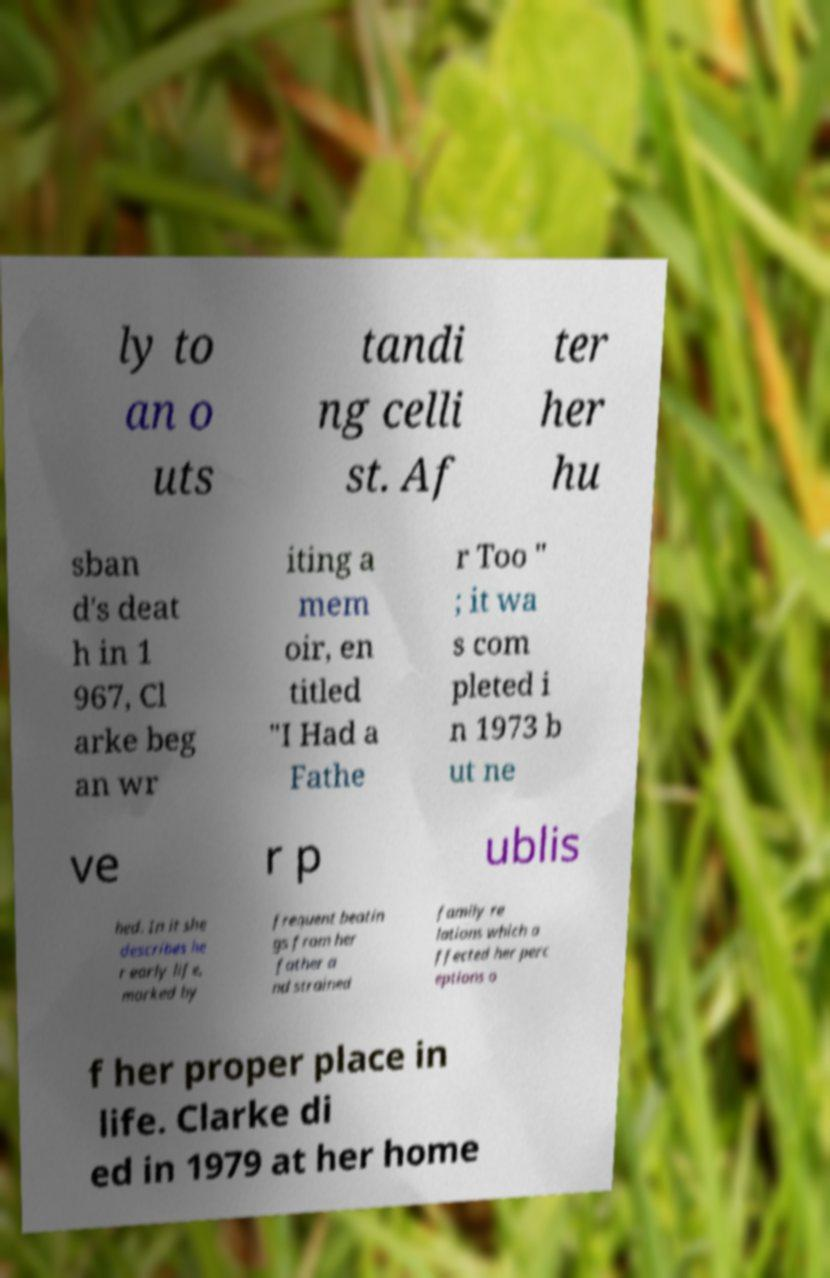Can you read and provide the text displayed in the image?This photo seems to have some interesting text. Can you extract and type it out for me? ly to an o uts tandi ng celli st. Af ter her hu sban d's deat h in 1 967, Cl arke beg an wr iting a mem oir, en titled "I Had a Fathe r Too " ; it wa s com pleted i n 1973 b ut ne ve r p ublis hed. In it she describes he r early life, marked by frequent beatin gs from her father a nd strained family re lations which a ffected her perc eptions o f her proper place in life. Clarke di ed in 1979 at her home 